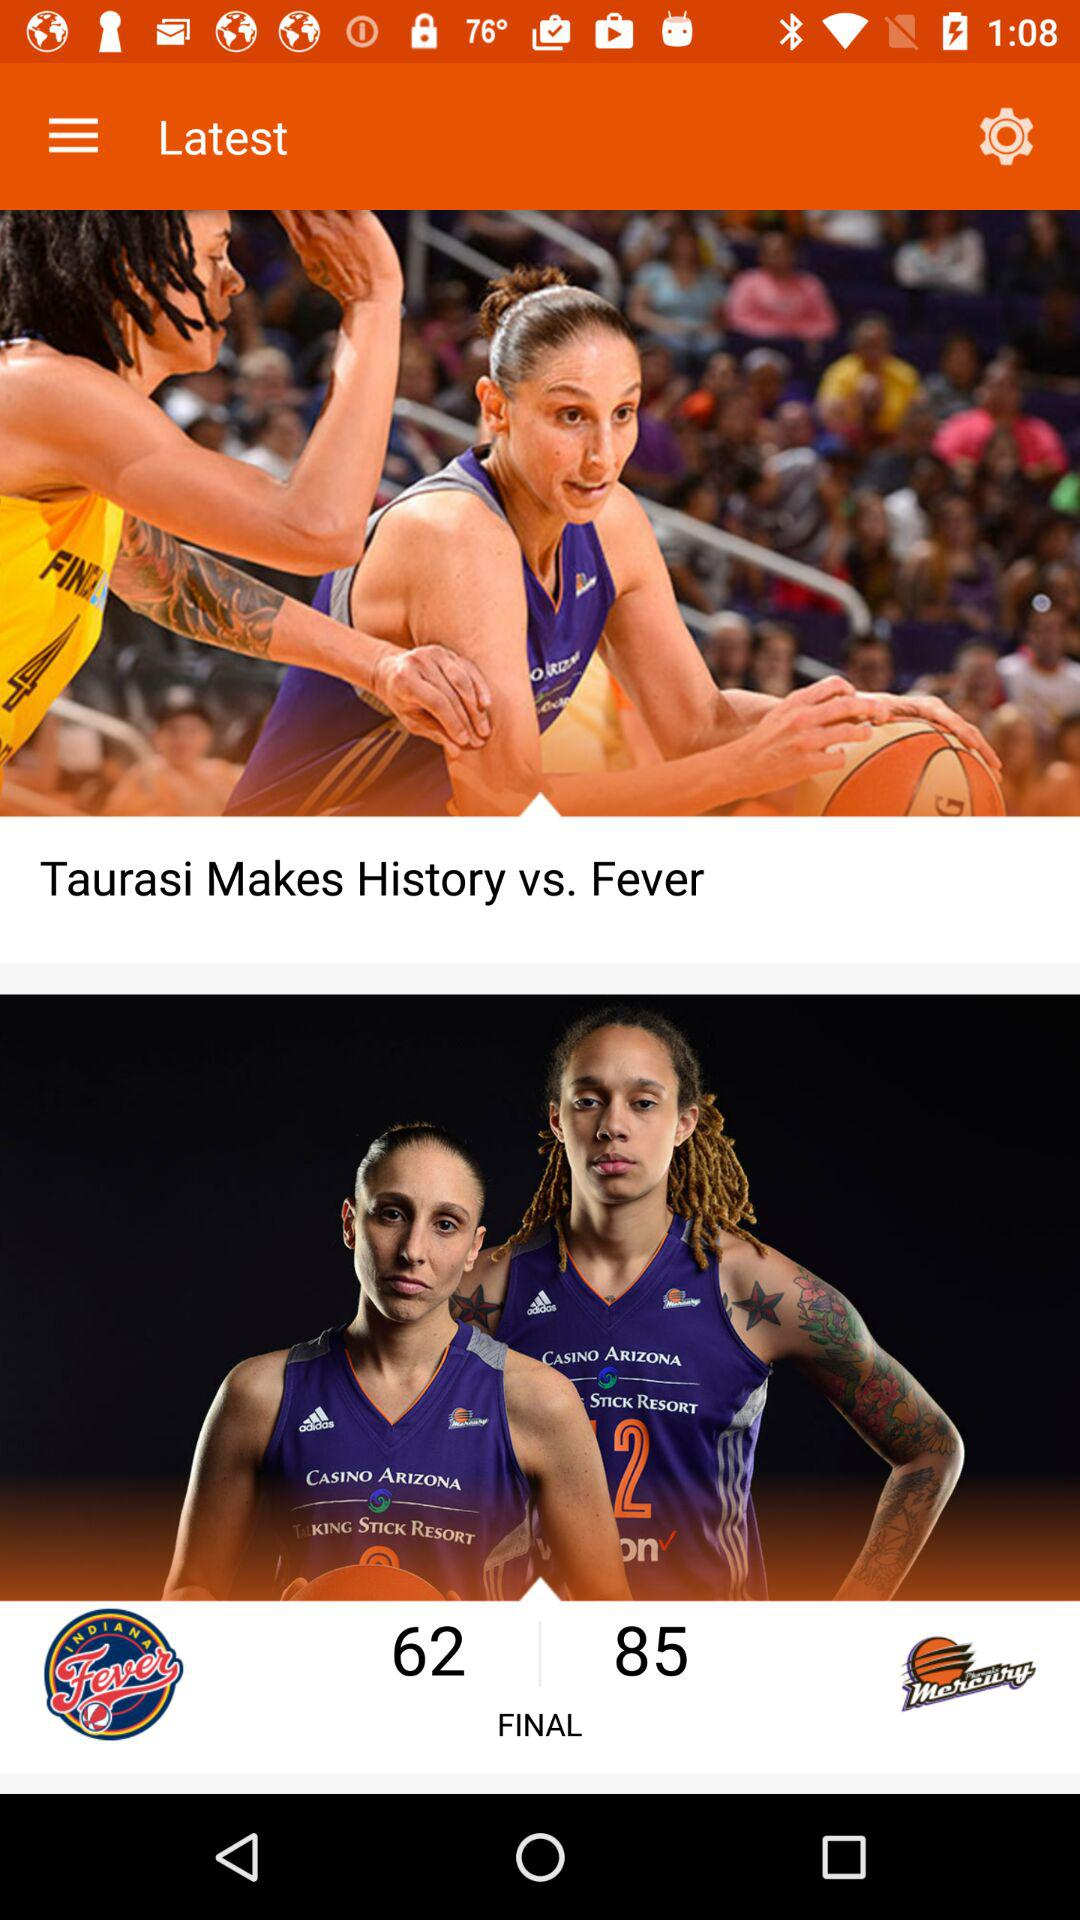What are the final scores of the two teams? The final scores of the two teams are 62 and 85. 